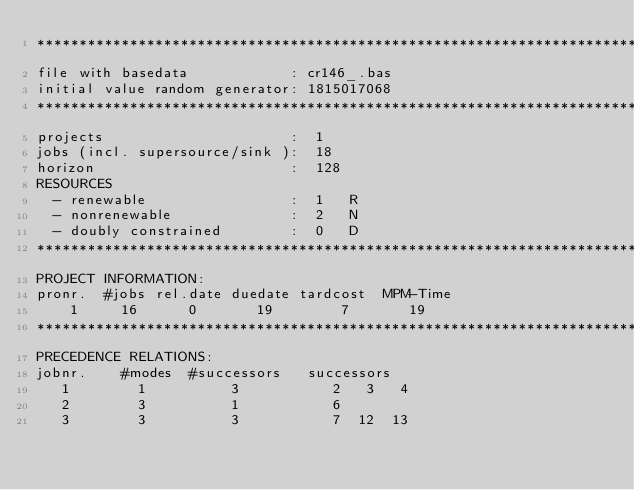Convert code to text. <code><loc_0><loc_0><loc_500><loc_500><_ObjectiveC_>************************************************************************
file with basedata            : cr146_.bas
initial value random generator: 1815017068
************************************************************************
projects                      :  1
jobs (incl. supersource/sink ):  18
horizon                       :  128
RESOURCES
  - renewable                 :  1   R
  - nonrenewable              :  2   N
  - doubly constrained        :  0   D
************************************************************************
PROJECT INFORMATION:
pronr.  #jobs rel.date duedate tardcost  MPM-Time
    1     16      0       19        7       19
************************************************************************
PRECEDENCE RELATIONS:
jobnr.    #modes  #successors   successors
   1        1          3           2   3   4
   2        3          1           6
   3        3          3           7  12  13</code> 